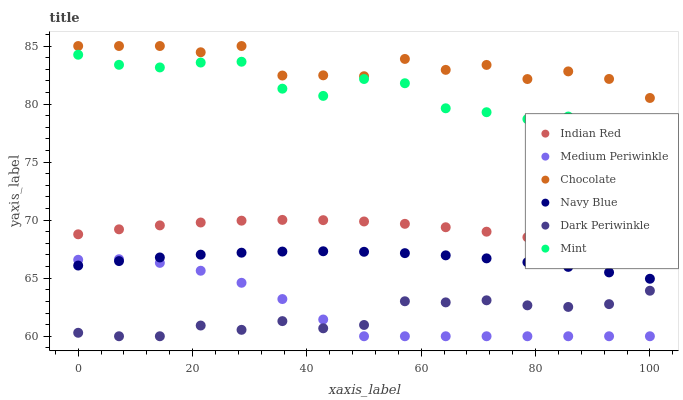Does Dark Periwinkle have the minimum area under the curve?
Answer yes or no. Yes. Does Chocolate have the maximum area under the curve?
Answer yes or no. Yes. Does Medium Periwinkle have the minimum area under the curve?
Answer yes or no. No. Does Medium Periwinkle have the maximum area under the curve?
Answer yes or no. No. Is Navy Blue the smoothest?
Answer yes or no. Yes. Is Chocolate the roughest?
Answer yes or no. Yes. Is Medium Periwinkle the smoothest?
Answer yes or no. No. Is Medium Periwinkle the roughest?
Answer yes or no. No. Does Medium Periwinkle have the lowest value?
Answer yes or no. Yes. Does Chocolate have the lowest value?
Answer yes or no. No. Does Chocolate have the highest value?
Answer yes or no. Yes. Does Medium Periwinkle have the highest value?
Answer yes or no. No. Is Navy Blue less than Indian Red?
Answer yes or no. Yes. Is Chocolate greater than Dark Periwinkle?
Answer yes or no. Yes. Does Medium Periwinkle intersect Dark Periwinkle?
Answer yes or no. Yes. Is Medium Periwinkle less than Dark Periwinkle?
Answer yes or no. No. Is Medium Periwinkle greater than Dark Periwinkle?
Answer yes or no. No. Does Navy Blue intersect Indian Red?
Answer yes or no. No. 